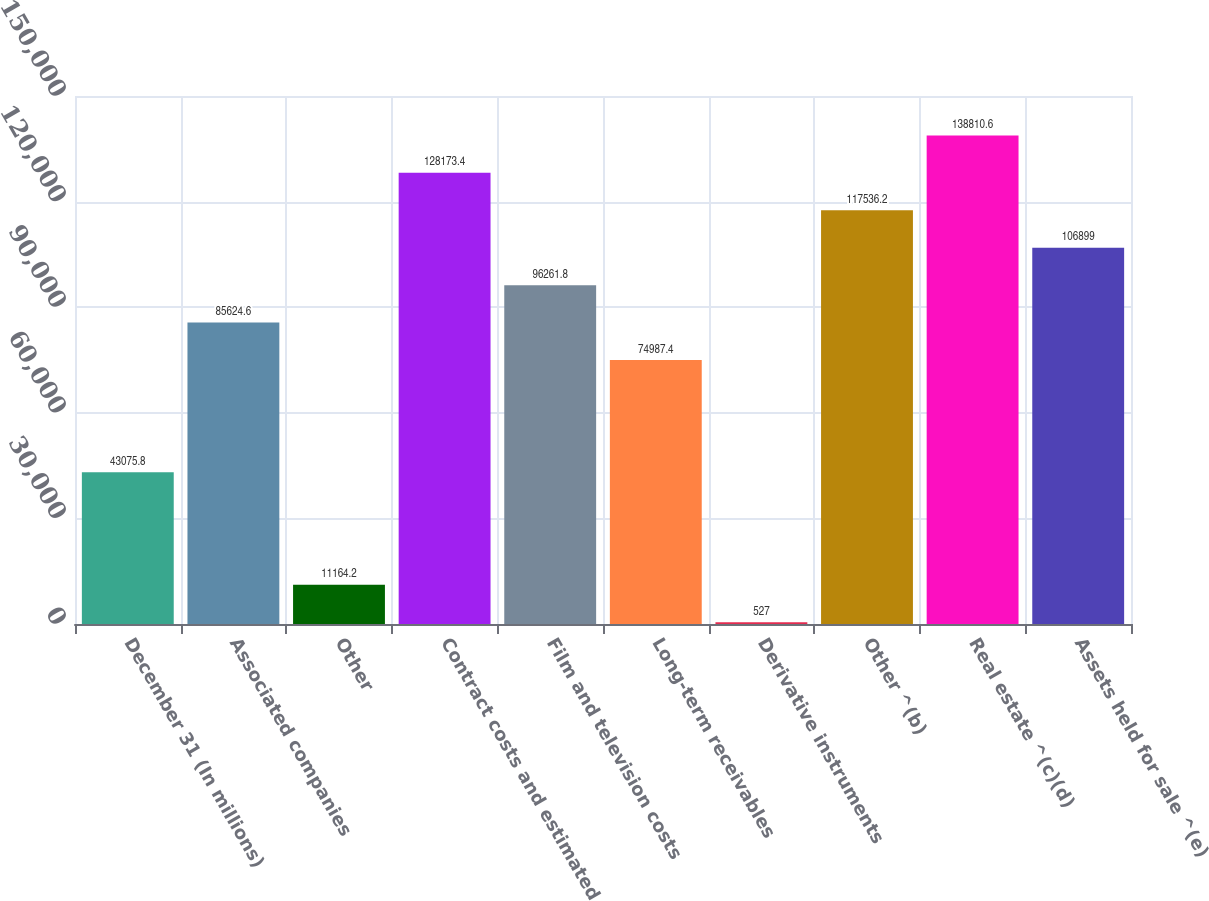<chart> <loc_0><loc_0><loc_500><loc_500><bar_chart><fcel>December 31 (In millions)<fcel>Associated companies<fcel>Other<fcel>Contract costs and estimated<fcel>Film and television costs<fcel>Long-term receivables<fcel>Derivative instruments<fcel>Other ^(b)<fcel>Real estate ^(c)(d)<fcel>Assets held for sale ^(e)<nl><fcel>43075.8<fcel>85624.6<fcel>11164.2<fcel>128173<fcel>96261.8<fcel>74987.4<fcel>527<fcel>117536<fcel>138811<fcel>106899<nl></chart> 